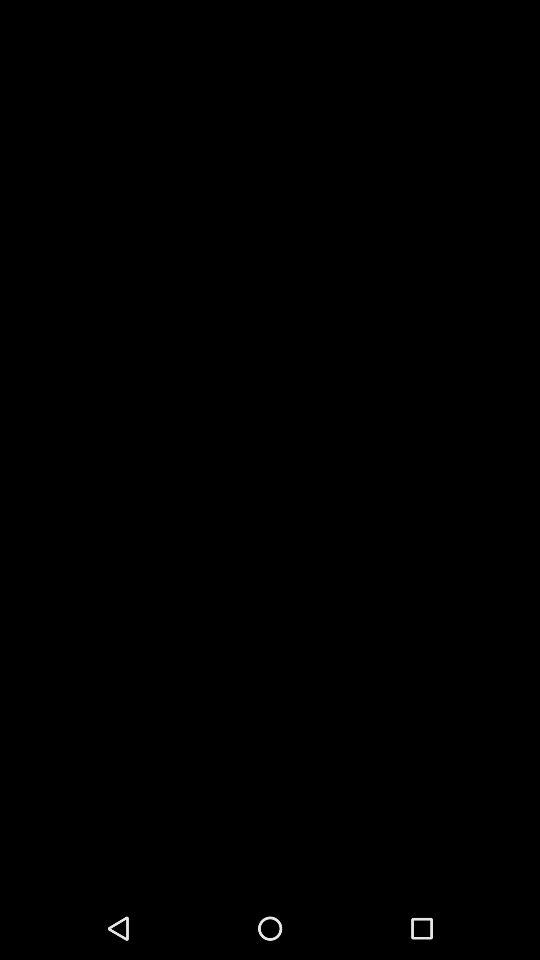How many items are available to select as the device type?
Answer the question using a single word or phrase. 2 